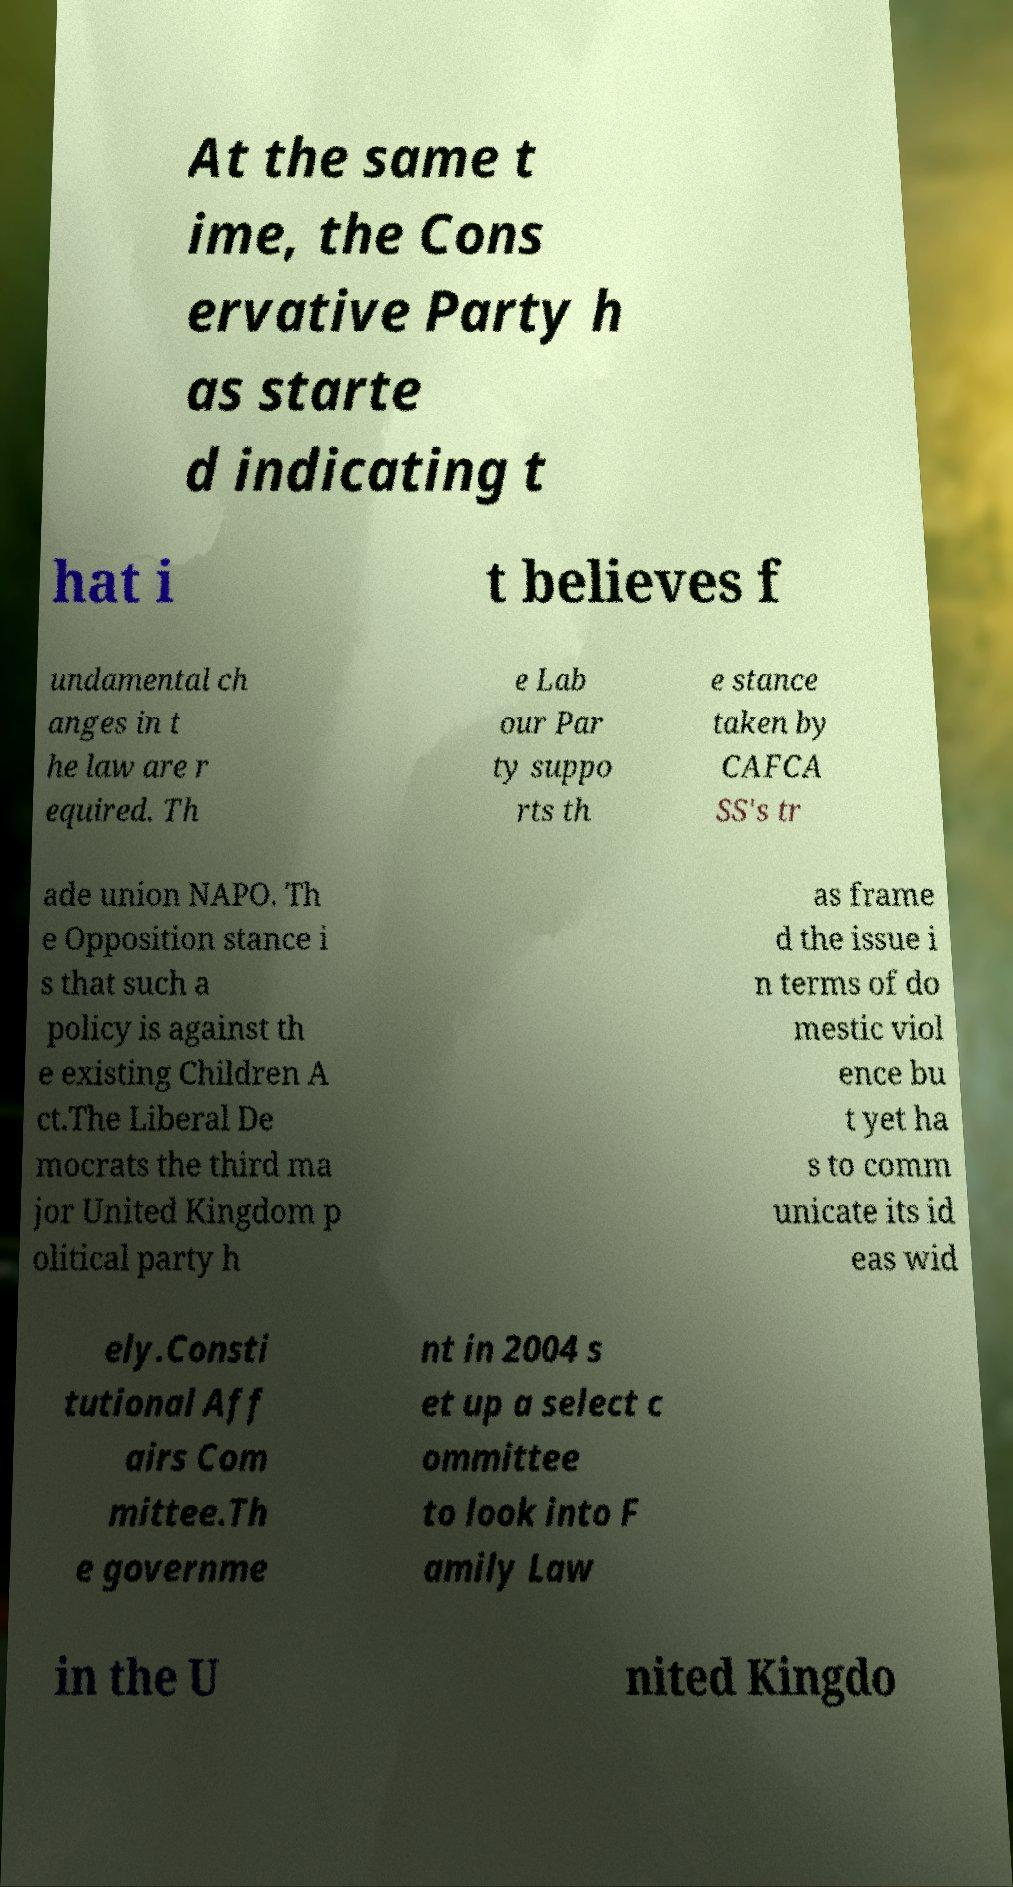For documentation purposes, I need the text within this image transcribed. Could you provide that? At the same t ime, the Cons ervative Party h as starte d indicating t hat i t believes f undamental ch anges in t he law are r equired. Th e Lab our Par ty suppo rts th e stance taken by CAFCA SS's tr ade union NAPO. Th e Opposition stance i s that such a policy is against th e existing Children A ct.The Liberal De mocrats the third ma jor United Kingdom p olitical party h as frame d the issue i n terms of do mestic viol ence bu t yet ha s to comm unicate its id eas wid ely.Consti tutional Aff airs Com mittee.Th e governme nt in 2004 s et up a select c ommittee to look into F amily Law in the U nited Kingdo 